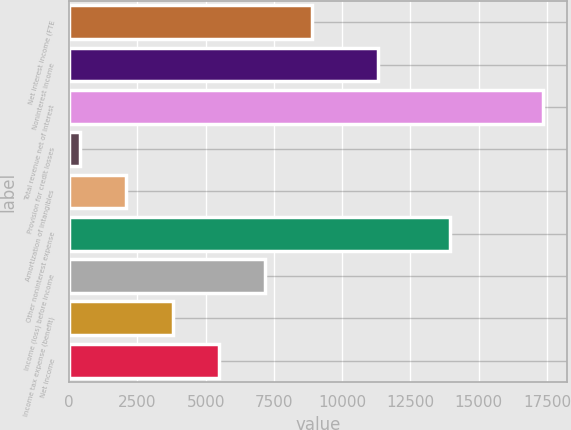<chart> <loc_0><loc_0><loc_500><loc_500><bar_chart><fcel>Net interest income (FTE<fcel>Noninterest income<fcel>Total revenue net of interest<fcel>Provision for credit losses<fcel>Amortization of intangibles<fcel>Other noninterest expense<fcel>Income (loss) before income<fcel>Income tax expense (benefit)<fcel>Net income<nl><fcel>8887<fcel>11330<fcel>17376<fcel>398<fcel>2095.8<fcel>13957<fcel>7189.2<fcel>3793.6<fcel>5491.4<nl></chart> 